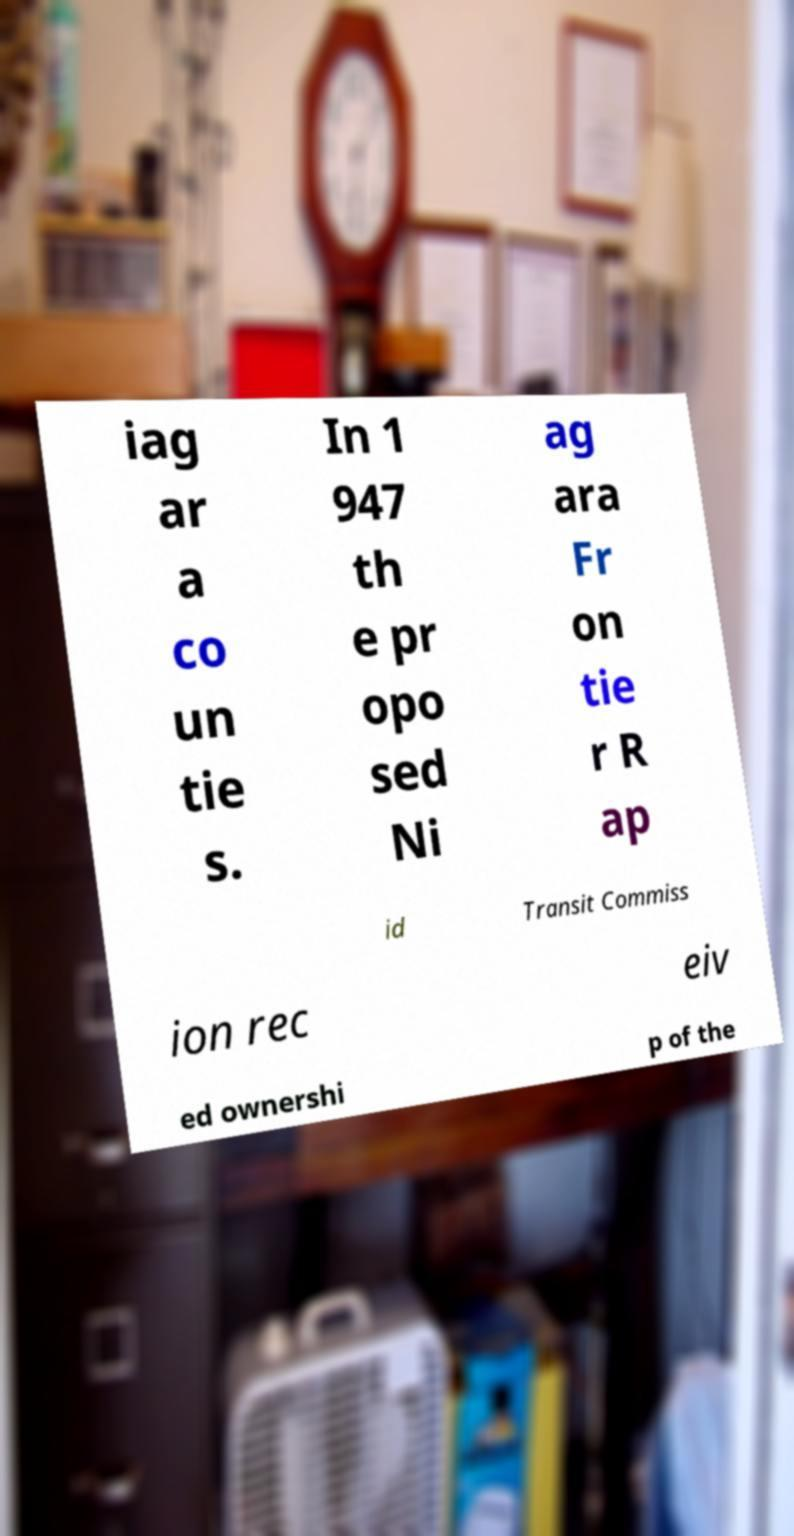What messages or text are displayed in this image? I need them in a readable, typed format. iag ar a co un tie s. In 1 947 th e pr opo sed Ni ag ara Fr on tie r R ap id Transit Commiss ion rec eiv ed ownershi p of the 